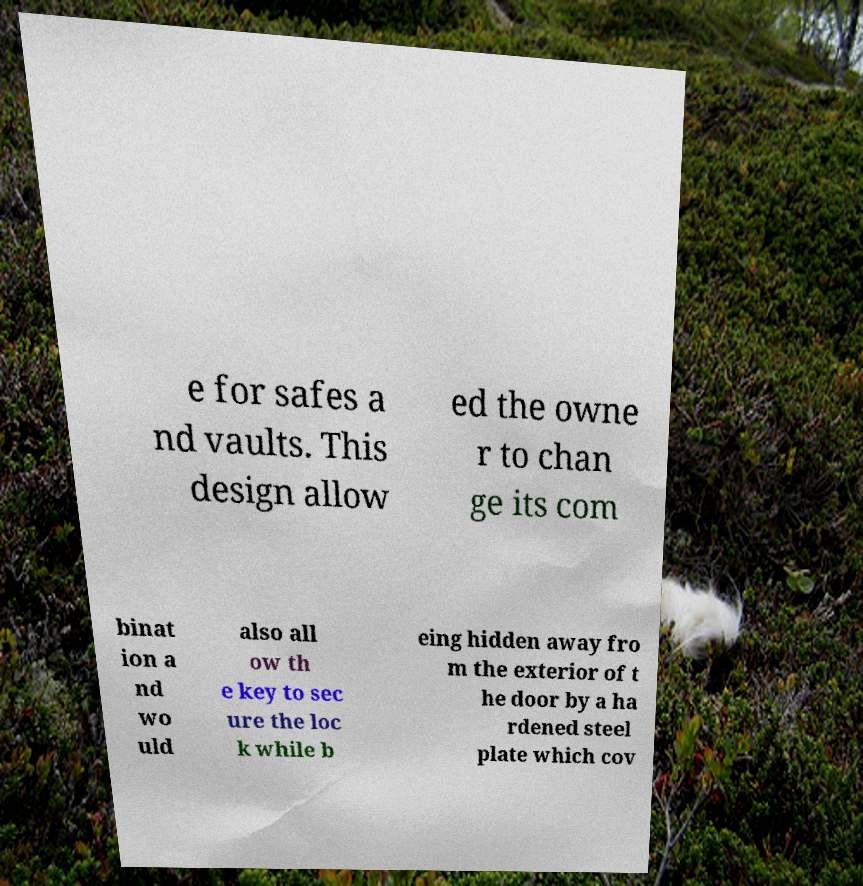There's text embedded in this image that I need extracted. Can you transcribe it verbatim? e for safes a nd vaults. This design allow ed the owne r to chan ge its com binat ion a nd wo uld also all ow th e key to sec ure the loc k while b eing hidden away fro m the exterior of t he door by a ha rdened steel plate which cov 